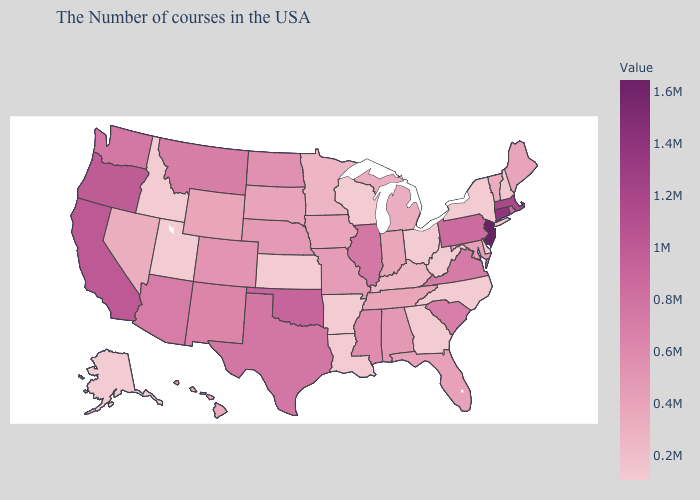Does New Jersey have the lowest value in the USA?
Quick response, please. No. Does Alaska have the lowest value in the West?
Keep it brief. Yes. Among the states that border Texas , does New Mexico have the lowest value?
Short answer required. No. Does Arkansas have the lowest value in the USA?
Answer briefly. Yes. Among the states that border New Hampshire , does Vermont have the lowest value?
Quick response, please. Yes. Does Florida have a lower value than Oklahoma?
Be succinct. Yes. 